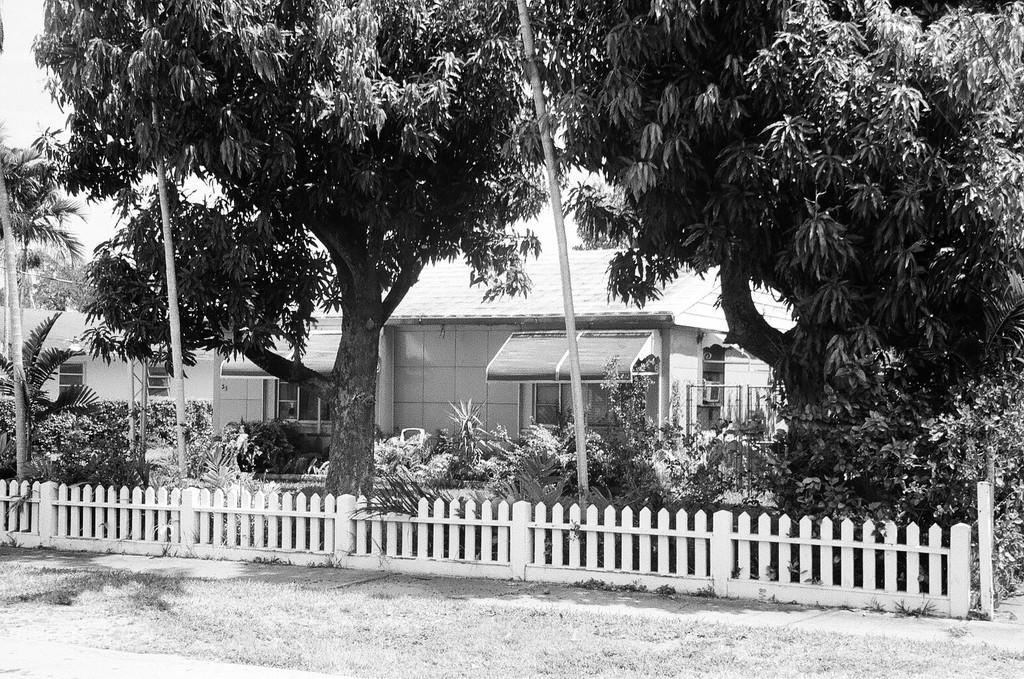What type of natural elements can be seen inside the fence in the image? There are trees inside a fence in the image. What other vegetation is present on the land in the image? There are plants on the land in the image. What type of structure can be seen in the background of the image? There is a building visible in the background of the image. How is the image presented in terms of color? The image is black and white. Can you see your uncle playing with a kitten in the fog in the image? There is no uncle, kitten, or fog present in the image; it is a black and white image featuring trees, plants, and a building. 